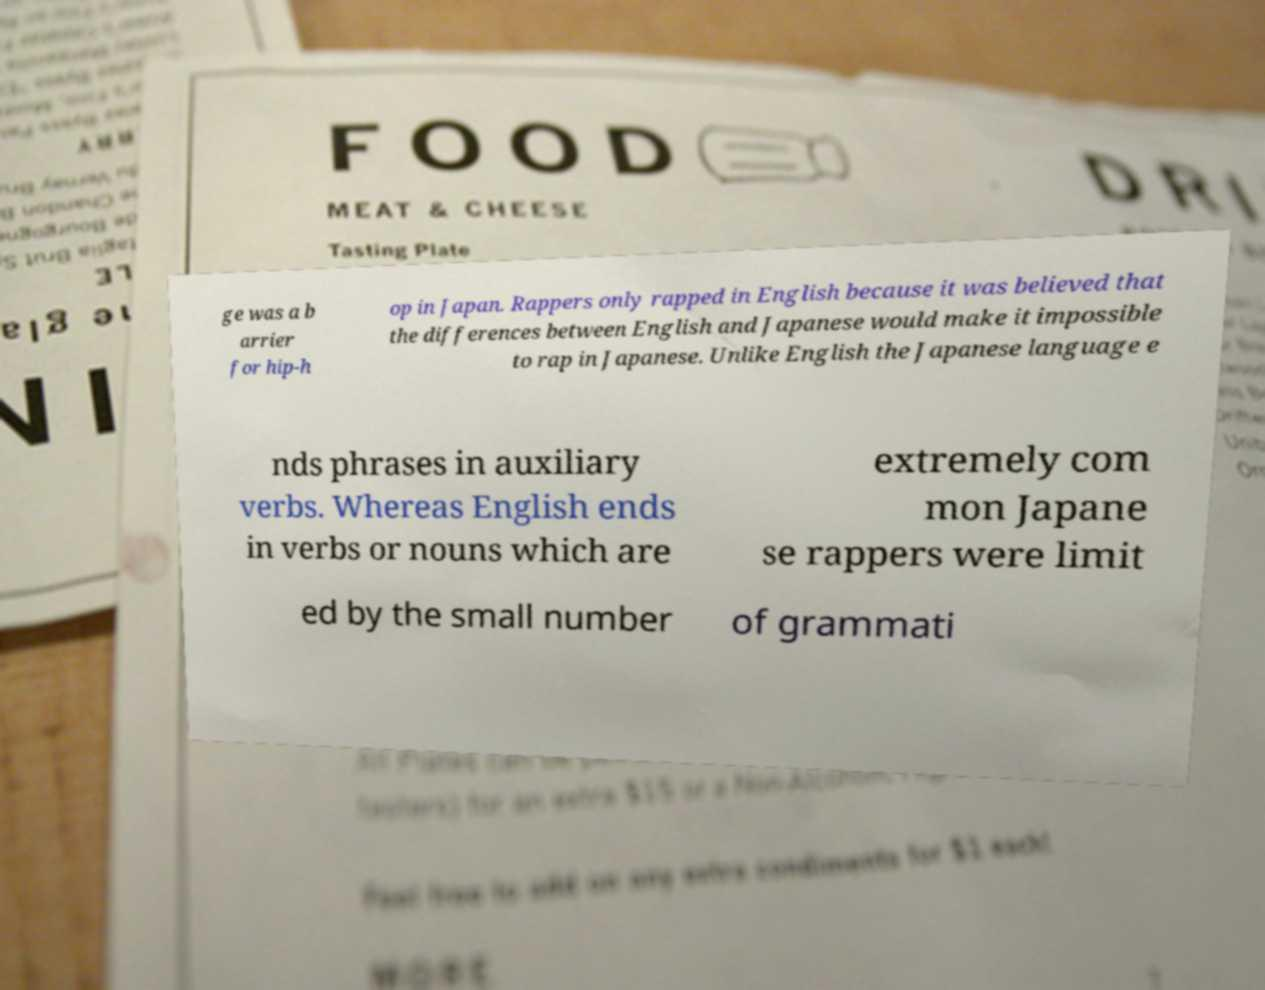Could you assist in decoding the text presented in this image and type it out clearly? ge was a b arrier for hip-h op in Japan. Rappers only rapped in English because it was believed that the differences between English and Japanese would make it impossible to rap in Japanese. Unlike English the Japanese language e nds phrases in auxiliary verbs. Whereas English ends in verbs or nouns which are extremely com mon Japane se rappers were limit ed by the small number of grammati 